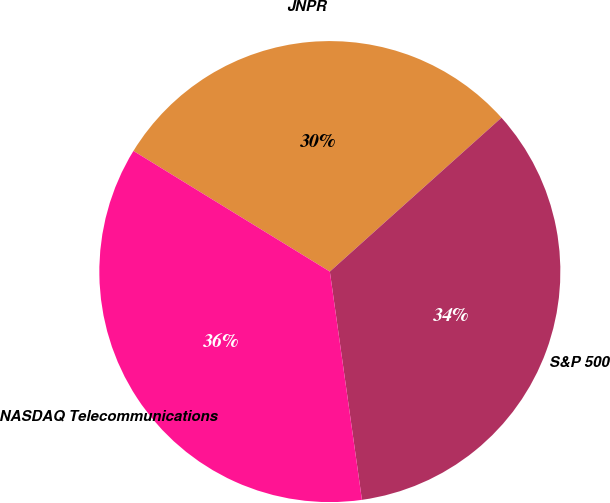<chart> <loc_0><loc_0><loc_500><loc_500><pie_chart><fcel>JNPR<fcel>S&P 500<fcel>NASDAQ Telecommunications<nl><fcel>29.6%<fcel>34.41%<fcel>35.99%<nl></chart> 